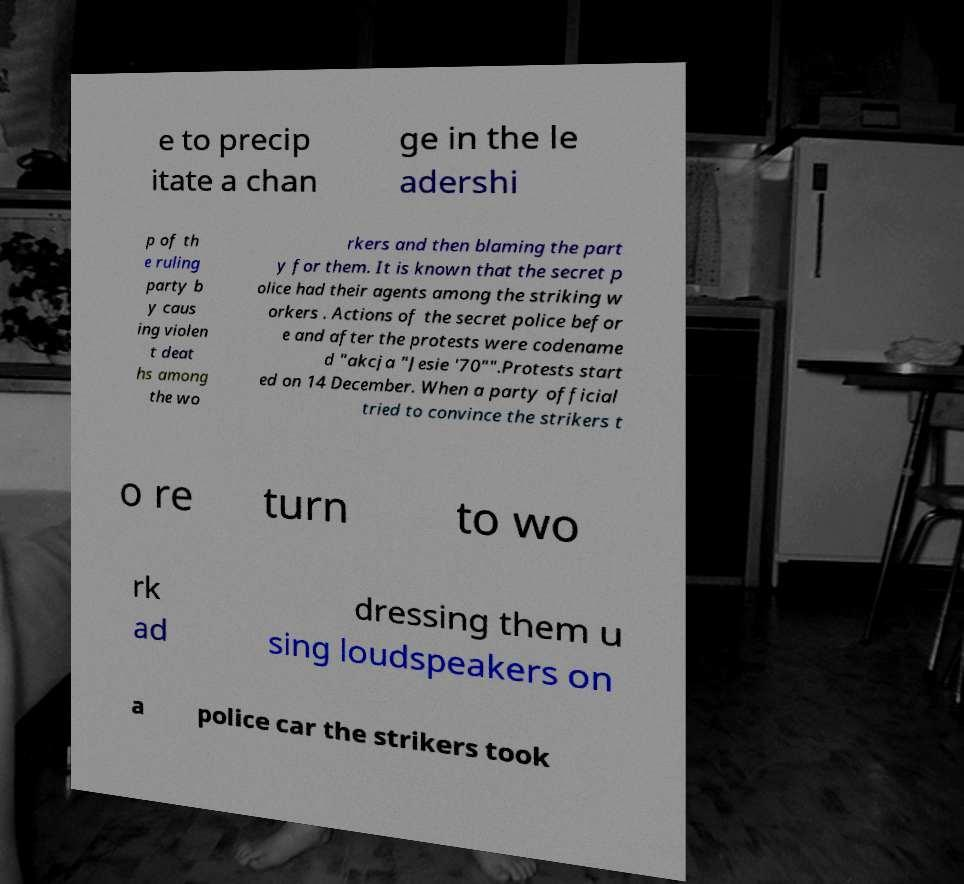For documentation purposes, I need the text within this image transcribed. Could you provide that? e to precip itate a chan ge in the le adershi p of th e ruling party b y caus ing violen t deat hs among the wo rkers and then blaming the part y for them. It is known that the secret p olice had their agents among the striking w orkers . Actions of the secret police befor e and after the protests were codename d "akcja "Jesie '70"".Protests start ed on 14 December. When a party official tried to convince the strikers t o re turn to wo rk ad dressing them u sing loudspeakers on a police car the strikers took 